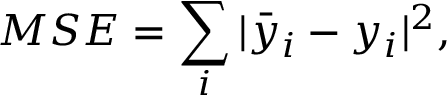Convert formula to latex. <formula><loc_0><loc_0><loc_500><loc_500>M S E = \sum _ { i } | \bar { y } _ { i } - y _ { i } | ^ { 2 } ,</formula> 